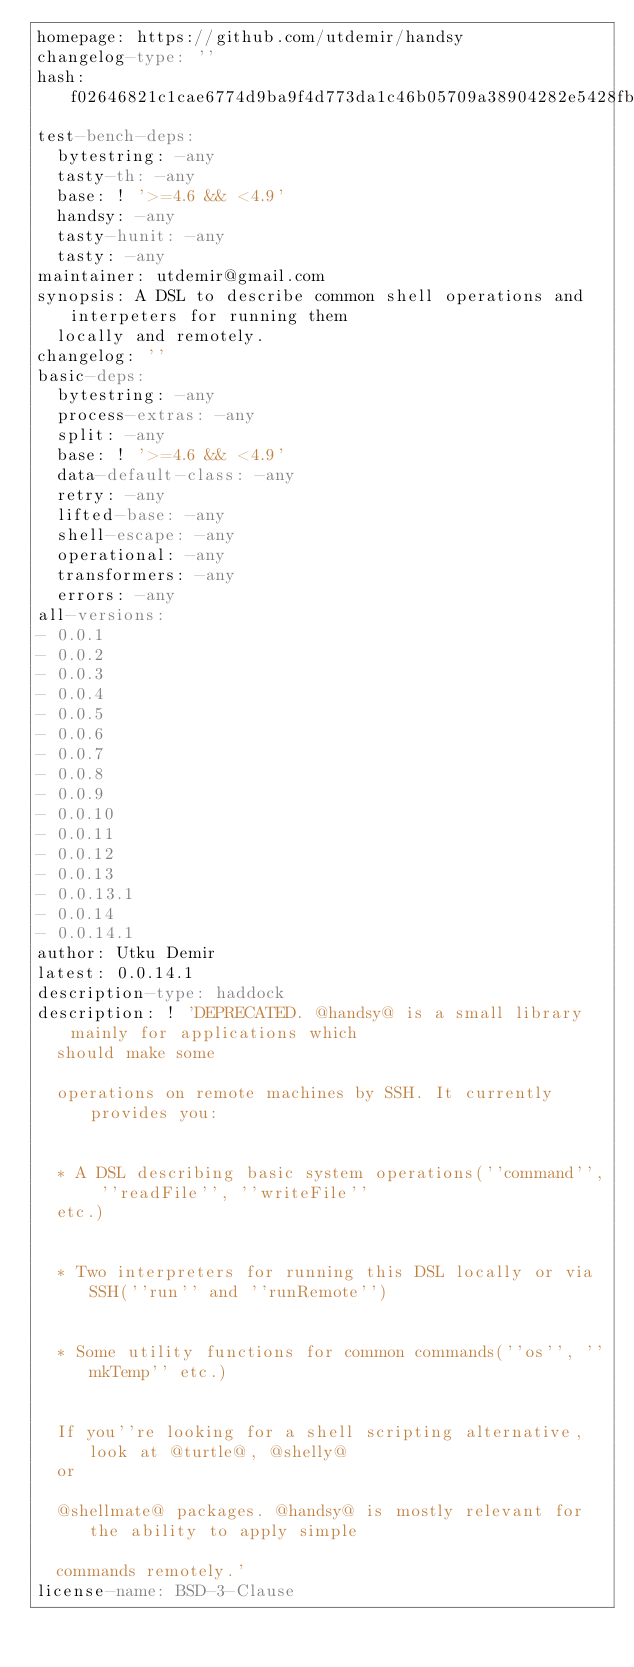Convert code to text. <code><loc_0><loc_0><loc_500><loc_500><_YAML_>homepage: https://github.com/utdemir/handsy
changelog-type: ''
hash: f02646821c1cae6774d9ba9f4d773da1c46b05709a38904282e5428fbddd0ce8
test-bench-deps:
  bytestring: -any
  tasty-th: -any
  base: ! '>=4.6 && <4.9'
  handsy: -any
  tasty-hunit: -any
  tasty: -any
maintainer: utdemir@gmail.com
synopsis: A DSL to describe common shell operations and interpeters for running them
  locally and remotely.
changelog: ''
basic-deps:
  bytestring: -any
  process-extras: -any
  split: -any
  base: ! '>=4.6 && <4.9'
  data-default-class: -any
  retry: -any
  lifted-base: -any
  shell-escape: -any
  operational: -any
  transformers: -any
  errors: -any
all-versions:
- 0.0.1
- 0.0.2
- 0.0.3
- 0.0.4
- 0.0.5
- 0.0.6
- 0.0.7
- 0.0.8
- 0.0.9
- 0.0.10
- 0.0.11
- 0.0.12
- 0.0.13
- 0.0.13.1
- 0.0.14
- 0.0.14.1
author: Utku Demir
latest: 0.0.14.1
description-type: haddock
description: ! 'DEPRECATED. @handsy@ is a small library mainly for applications which
  should make some

  operations on remote machines by SSH. It currently provides you:


  * A DSL describing basic system operations(''command'', ''readFile'', ''writeFile''
  etc.)


  * Two interpreters for running this DSL locally or via SSH(''run'' and ''runRemote'')


  * Some utility functions for common commands(''os'', ''mkTemp'' etc.)


  If you''re looking for a shell scripting alternative, look at @turtle@, @shelly@
  or

  @shellmate@ packages. @handsy@ is mostly relevant for the ability to apply simple

  commands remotely.'
license-name: BSD-3-Clause
</code> 